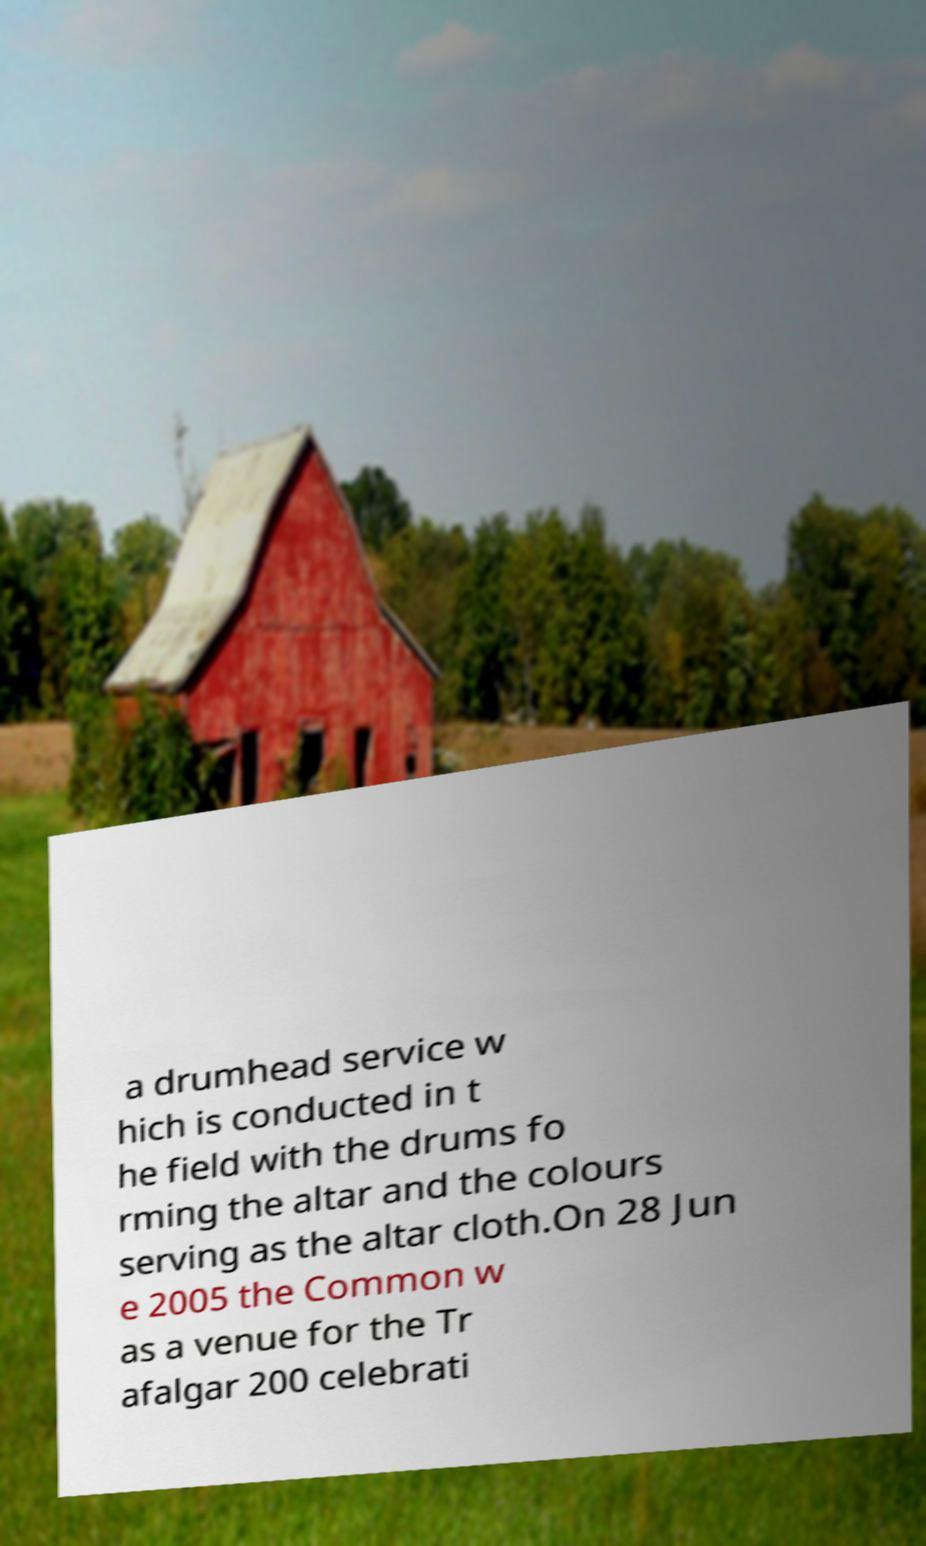What messages or text are displayed in this image? I need them in a readable, typed format. a drumhead service w hich is conducted in t he field with the drums fo rming the altar and the colours serving as the altar cloth.On 28 Jun e 2005 the Common w as a venue for the Tr afalgar 200 celebrati 